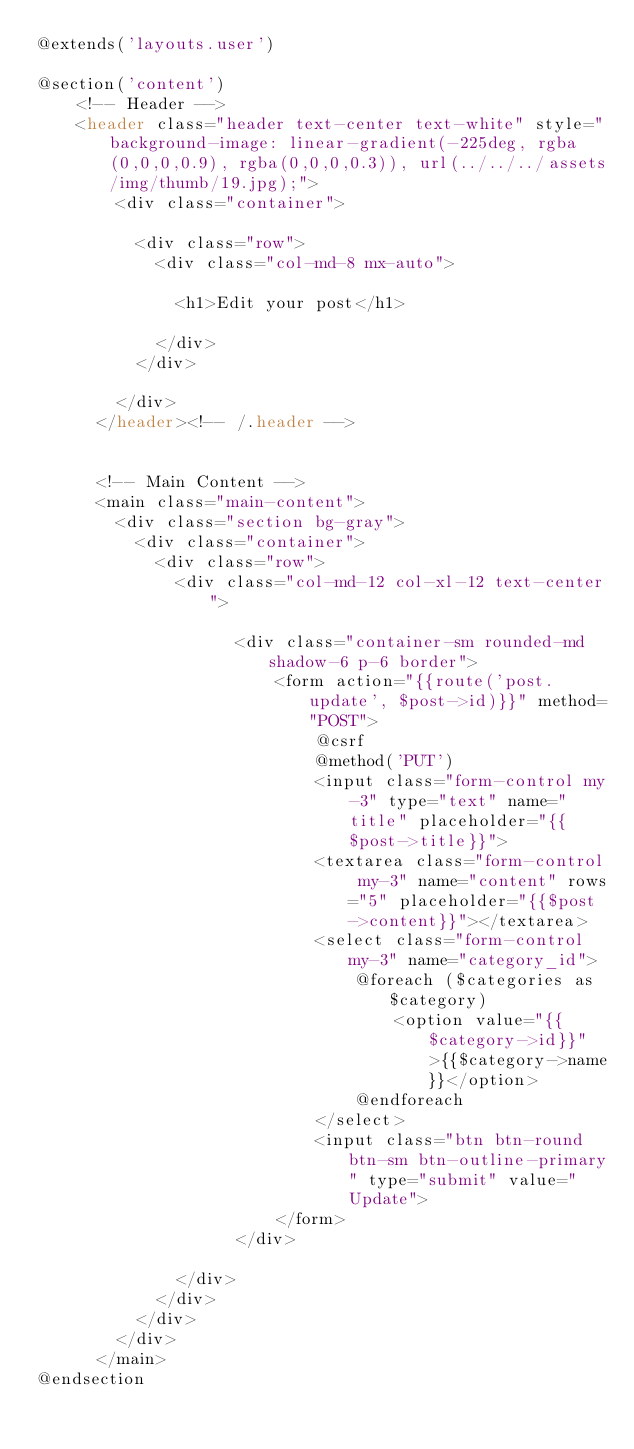<code> <loc_0><loc_0><loc_500><loc_500><_PHP_>@extends('layouts.user')

@section('content')
    <!-- Header -->
    <header class="header text-center text-white" style="background-image: linear-gradient(-225deg, rgba(0,0,0,0.9), rgba(0,0,0,0.3)), url(../../../assets/img/thumb/19.jpg);">
        <div class="container">
  
          <div class="row">
            <div class="col-md-8 mx-auto">
  
              <h1>Edit your post</h1>
  
            </div>
          </div>
  
        </div>
      </header><!-- /.header -->
  
  
      <!-- Main Content -->
      <main class="main-content">
        <div class="section bg-gray">
          <div class="container">
            <div class="row">
              <div class="col-md-12 col-xl-12 text-center">
  
                    <div class="container-sm rounded-md shadow-6 p-6 border">
                        <form action="{{route('post.update', $post->id)}}" method="POST">
                            @csrf
                            @method('PUT')
                            <input class="form-control my-3" type="text" name="title" placeholder="{{$post->title}}">
                            <textarea class="form-control my-3" name="content" rows="5" placeholder="{{$post->content}}"></textarea>
                            <select class="form-control my-3" name="category_id">
                                @foreach ($categories as $category)
                                    <option value="{{$category->id}}">{{$category->name}}</option>
                                @endforeach
                            </select>
                            <input class="btn btn-round btn-sm btn-outline-primary" type="submit" value="Update">
                        </form>
                    </div>
  
              </div>
            </div>
          </div>
        </div>
      </main>
@endsection
</code> 